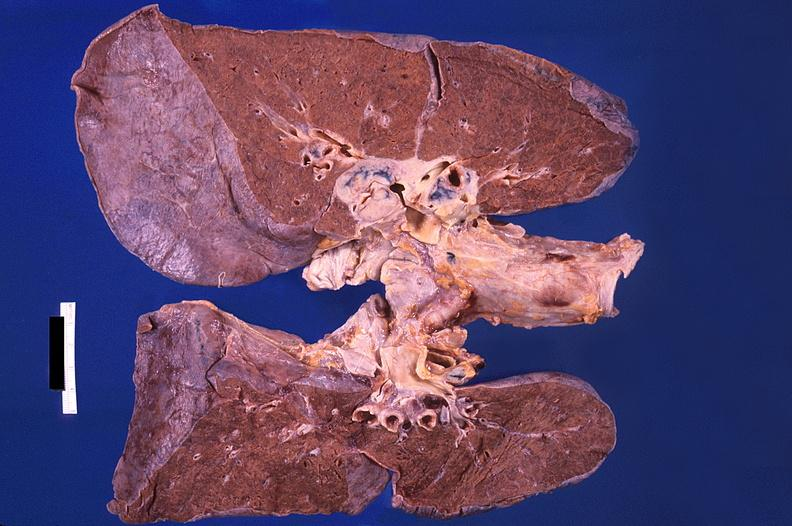what does this image show?
Answer the question using a single word or phrase. Hilar lymph nodes 